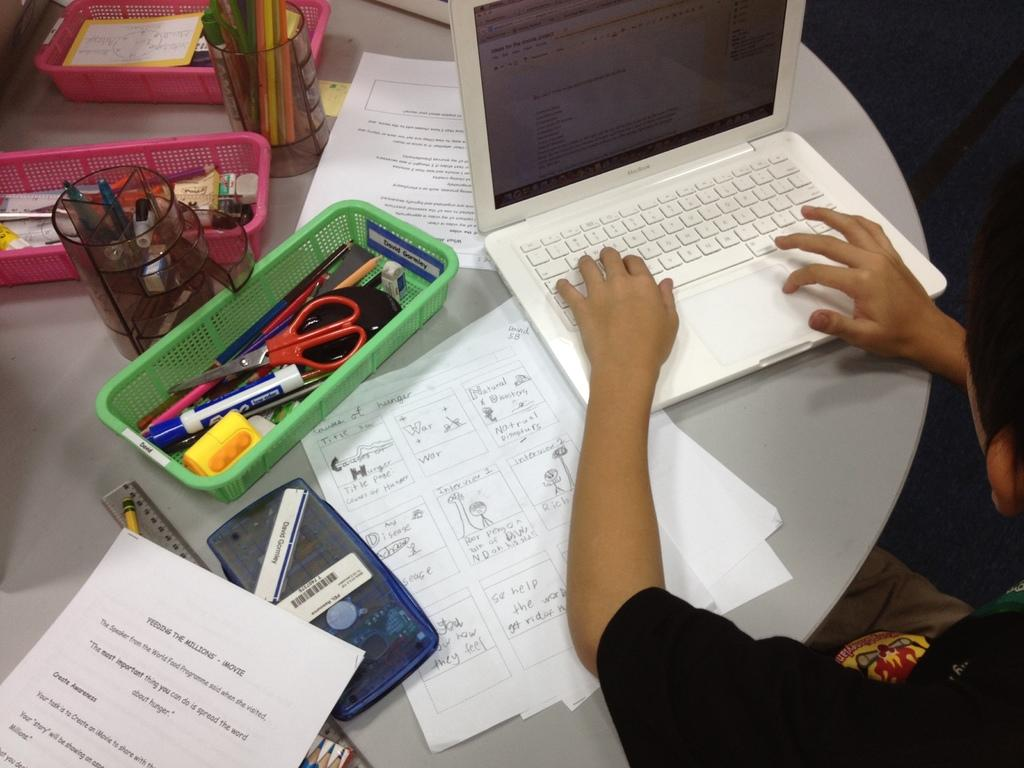Provide a one-sentence caption for the provided image. A child at a table working on schoolwork and a assignment on the causes of hunger. 